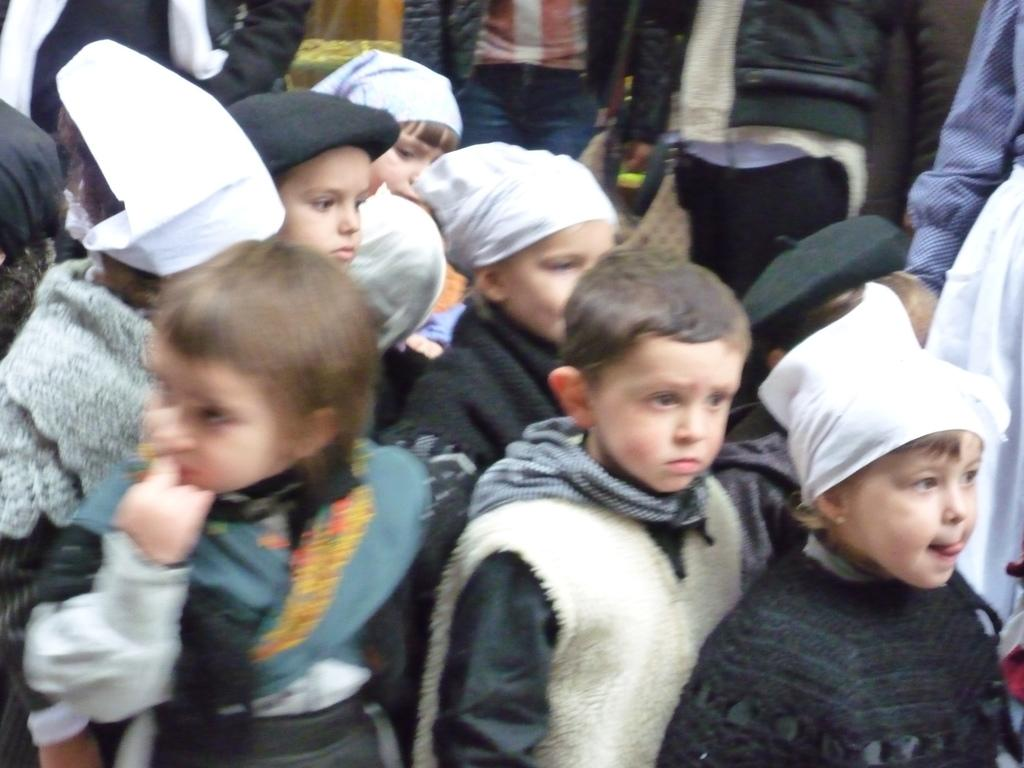What can be seen in the image? There is a group of children and men standing in the image. Can you describe the children in the image? The provided facts do not give specific details about the children, but they are part of the group visible in the image. What can be said about the men in the image? The provided facts only mention that there are men standing in the image, but no further details are given. Where is the frog in the image? There is no frog present in the image. What is the reason for the good-bye in the image? The provided facts do not mention any good-byes or reasons for them in the image. 